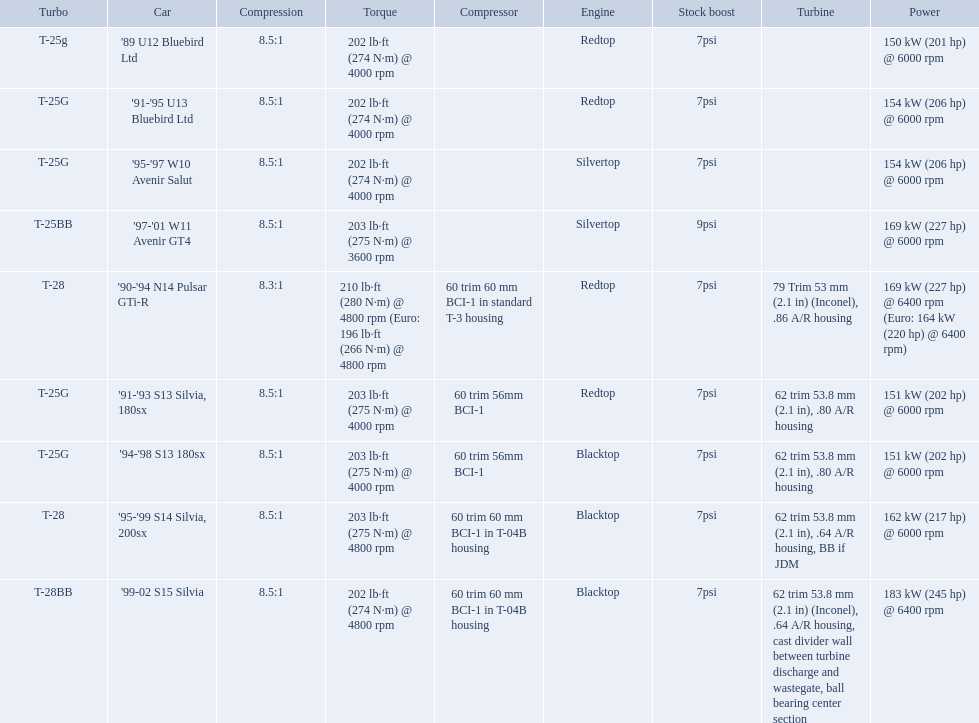What are all the cars? '89 U12 Bluebird Ltd, '91-'95 U13 Bluebird Ltd, '95-'97 W10 Avenir Salut, '97-'01 W11 Avenir GT4, '90-'94 N14 Pulsar GTi-R, '91-'93 S13 Silvia, 180sx, '94-'98 S13 180sx, '95-'99 S14 Silvia, 200sx, '99-02 S15 Silvia. What are their stock boosts? 7psi, 7psi, 7psi, 9psi, 7psi, 7psi, 7psi, 7psi, 7psi. And which car has the highest stock boost? '97-'01 W11 Avenir GT4. What cars are there? '89 U12 Bluebird Ltd, 7psi, '91-'95 U13 Bluebird Ltd, 7psi, '95-'97 W10 Avenir Salut, 7psi, '97-'01 W11 Avenir GT4, 9psi, '90-'94 N14 Pulsar GTi-R, 7psi, '91-'93 S13 Silvia, 180sx, 7psi, '94-'98 S13 180sx, 7psi, '95-'99 S14 Silvia, 200sx, 7psi, '99-02 S15 Silvia, 7psi. Which stock boost is over 7psi? '97-'01 W11 Avenir GT4, 9psi. What car is it? '97-'01 W11 Avenir GT4. 